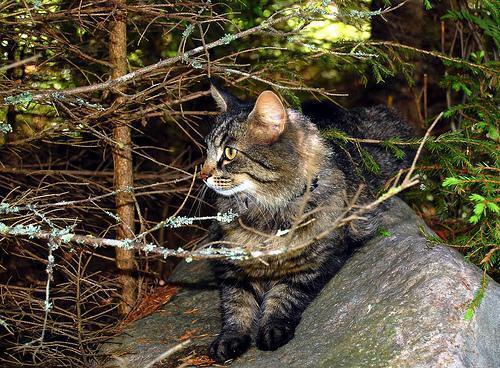How many cats are there?
Give a very brief answer. 1. 